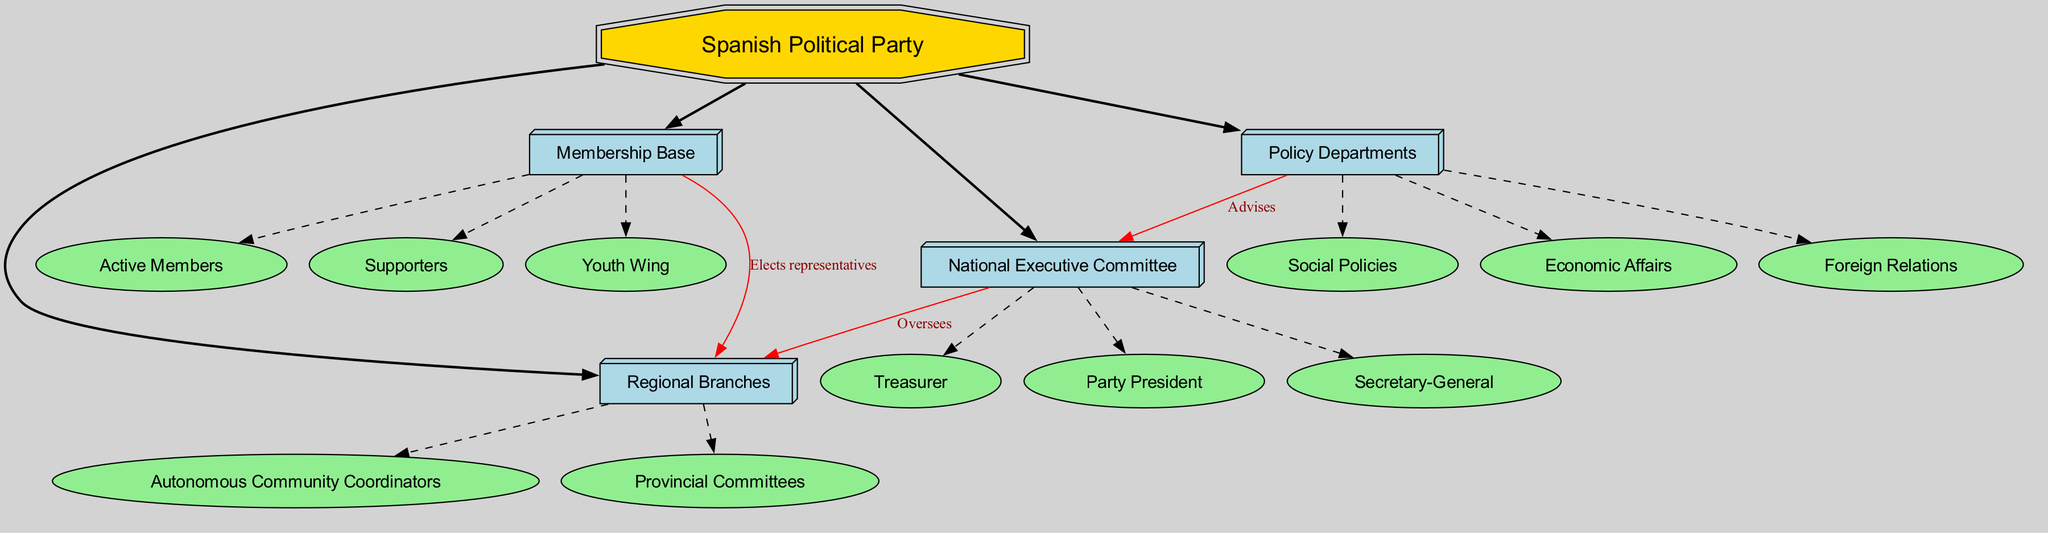What is the main block of the diagram? The top-level node in the diagram is labeled "Spanish Political Party," which represents the overarching entity being described.
Answer: Spanish Political Party How many sub blocks are there? The diagram presents four distinct sub blocks, which are key categories under the main block.
Answer: 4 Who oversees the regional branches? The connection in the diagram indicates that the "National Executive Committee" oversees the "Regional Branches," meaning this committee holds responsibility for these divisions.
Answer: National Executive Committee Which role is part of the National Executive Committee? The diagram specifies three roles as part of the "National Executive Committee": "Party President," "Secretary-General," and "Treasurer," indicating their membership within this structure.
Answer: Party President What do the Policy Departments do in relation to the National Executive Committee? According to the diagram, the "Policy Departments" have a relationship where they advise the "National Executive Committee," suggesting a shared communication channel for policy suggestions.
Answer: Advises How many children does the "Membership Base" have? In the diagram, the "Membership Base" is shown to have three children nodes beneath it: "Active Members," "Supporters," and "Youth Wing," indicating its subdivisions within the organizational structure.
Answer: 3 What role does the Membership Base play with the Regional Branches? The diagram illustrates that the "Membership Base" elects representatives for the "Regional Branches," indicating a participatory role in the governance of these branches.
Answer: Elects representatives Which department deals with foreign relations? Looking at the "Policy Departments," "Foreign Relations" is explicitly listed as one of the departments within this block, indicating its focus area.
Answer: Foreign Relations What is the relationship between the "Policy Departments" and the "National Executive Committee"? The diagram establishes a directional connection where "Policy Departments" advise the "National Executive Committee," showing the advisory role of these departments.
Answer: Advises 